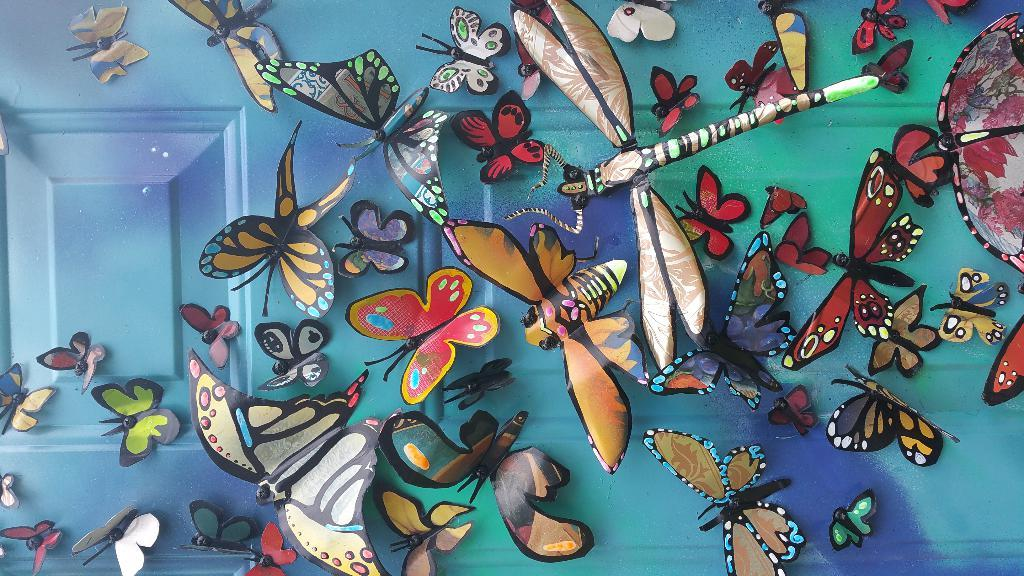What is featured on the wooden door in the image? There are depictions of butterflies on a wooden door in the image. Can you hear the sound of a whistle in the image? There is no whistle present in the image; it only features a wooden door with butterfly depictions. What degree of education is required to understand the image? The image does not require any specific degree of education to understand; it simply features a wooden door with butterfly depictions. 